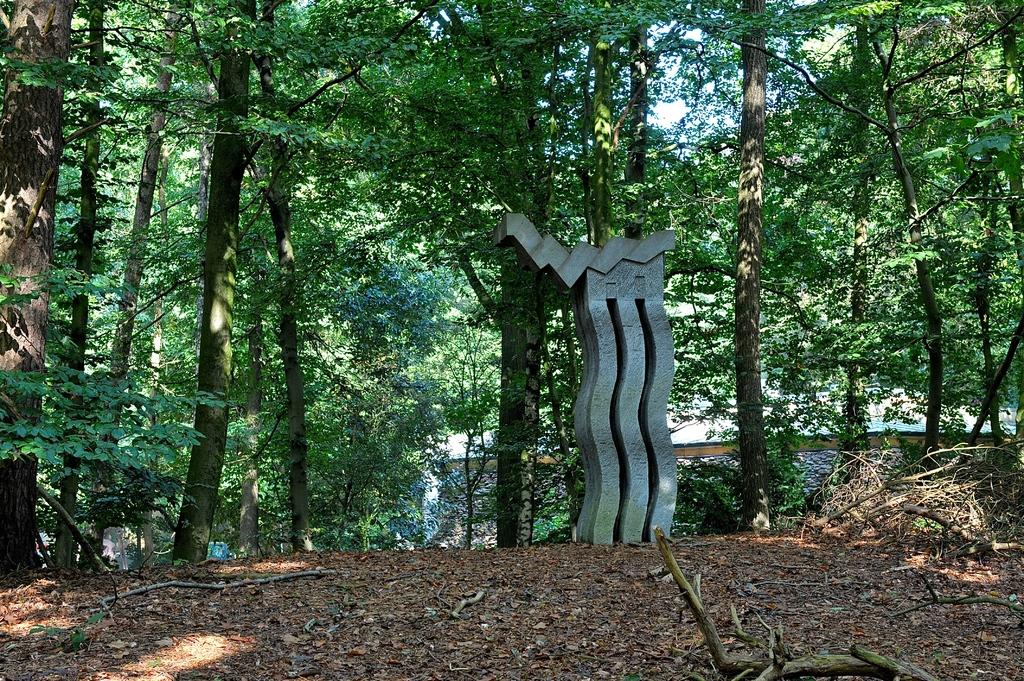What can be seen on the soil in the foreground of the image? There are dry leaves on the soil in the foreground of the image. What is the main object in the image? There is an object in the image, but its specific nature is not mentioned in the facts. What type of vegetation surrounds the object in the image? There are trees surrounding the object in the image. Are there any cherries hanging from the trees in the image? There is no mention of cherries in the provided facts, so we cannot determine if they are present in the image. Can you tell if the object in the image is a symbol of hate? The provided facts do not give any information about the nature or symbolism of the object in the image, so we cannot determine if it represents hate. 